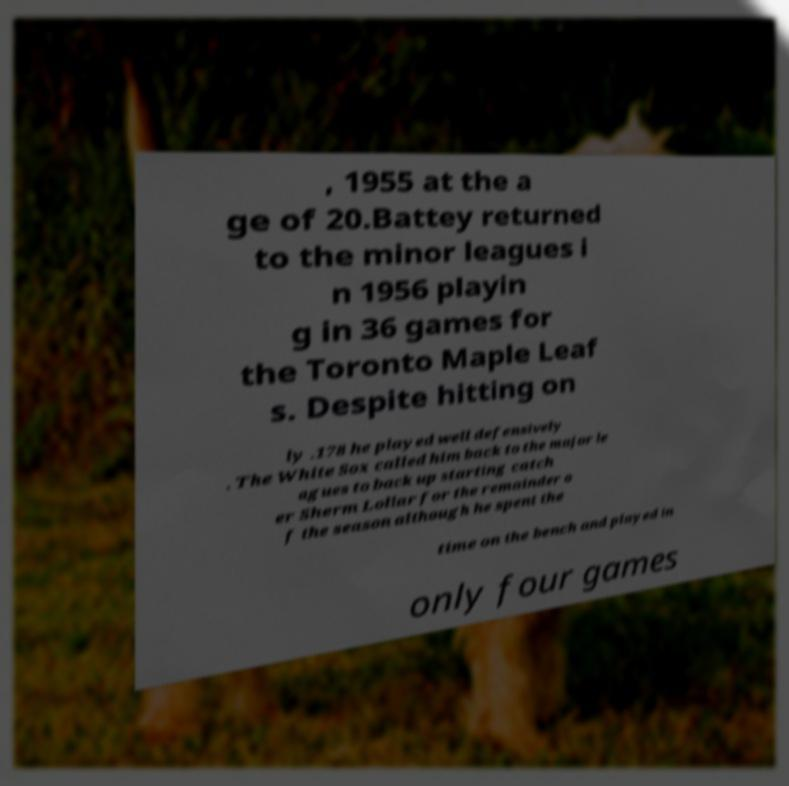I need the written content from this picture converted into text. Can you do that? , 1955 at the a ge of 20.Battey returned to the minor leagues i n 1956 playin g in 36 games for the Toronto Maple Leaf s. Despite hitting on ly .178 he played well defensively . The White Sox called him back to the major le agues to back up starting catch er Sherm Lollar for the remainder o f the season although he spent the time on the bench and played in only four games 